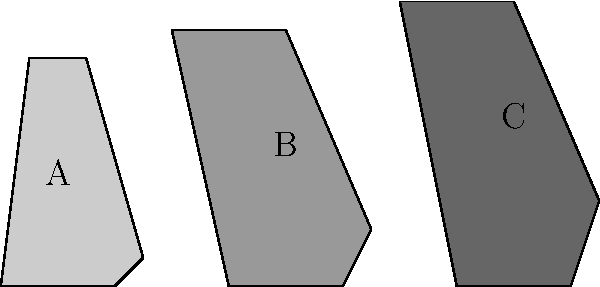Which of the trophies shown above most closely resembles the design of the Coppa Italia Serie C, won by U.S. Cremonese in the 1976-77 season? To answer this question, let's analyze each trophy design and compare it to the Coppa Italia Serie C won by U.S. Cremonese in 1976-77:

1. Trophy A: This is a shorter, wider design with a small base and a relatively flat top.

2. Trophy B: This trophy has a medium height with a slightly wider base and a more pronounced taper towards the top.

3. Trophy C: This is the tallest trophy with the narrowest base and the most significant taper towards the top.

The Coppa Italia Serie C, which U.S. Cremonese won in the 1976-77 season, is known for its distinctive tall and slender design. It typically has a narrow base that widens slightly before tapering to a point at the top.

Comparing this description to the given options:
- Trophy A is too short and wide to match the Coppa Italia Serie C.
- Trophy B is closer in shape but still not tall or tapered enough.
- Trophy C most closely resembles the Coppa Italia Serie C with its tall, slender design and significant taper from base to top.

Therefore, Trophy C is the closest match to the Coppa Italia Serie C won by U.S. Cremonese in 1976-77.
Answer: C 